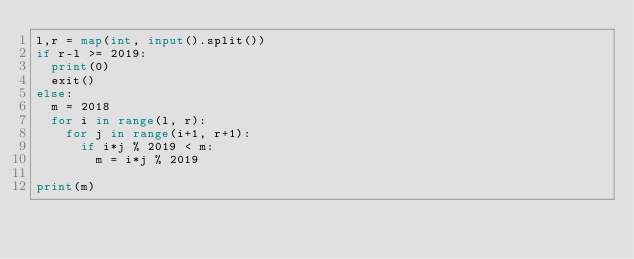Convert code to text. <code><loc_0><loc_0><loc_500><loc_500><_Python_>l,r = map(int, input().split())
if r-l >= 2019:
  print(0)
  exit()
else:
  m = 2018
  for i in range(l, r):
    for j in range(i+1, r+1):
      if i*j % 2019 < m:
        m = i*j % 2019

print(m)</code> 